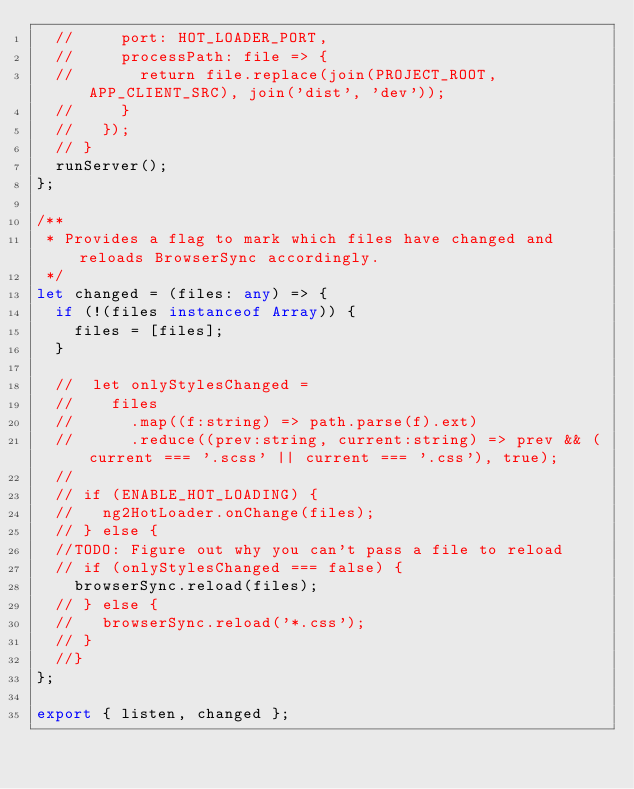Convert code to text. <code><loc_0><loc_0><loc_500><loc_500><_TypeScript_>  //     port: HOT_LOADER_PORT,
  //     processPath: file => {
  //       return file.replace(join(PROJECT_ROOT, APP_CLIENT_SRC), join('dist', 'dev'));
  //     }
  //   });
  // }
  runServer();
};

/**
 * Provides a flag to mark which files have changed and reloads BrowserSync accordingly.
 */
let changed = (files: any) => {
  if (!(files instanceof Array)) {
    files = [files];
  }

  //  let onlyStylesChanged =
  //    files
  //      .map((f:string) => path.parse(f).ext)
  //      .reduce((prev:string, current:string) => prev && (current === '.scss' || current === '.css'), true);
  //
  // if (ENABLE_HOT_LOADING) {
  //   ng2HotLoader.onChange(files);
  // } else {
  //TODO: Figure out why you can't pass a file to reload
  // if (onlyStylesChanged === false) {
    browserSync.reload(files);
  // } else {
  //   browserSync.reload('*.css');
  // }
  //}
};

export { listen, changed };
</code> 